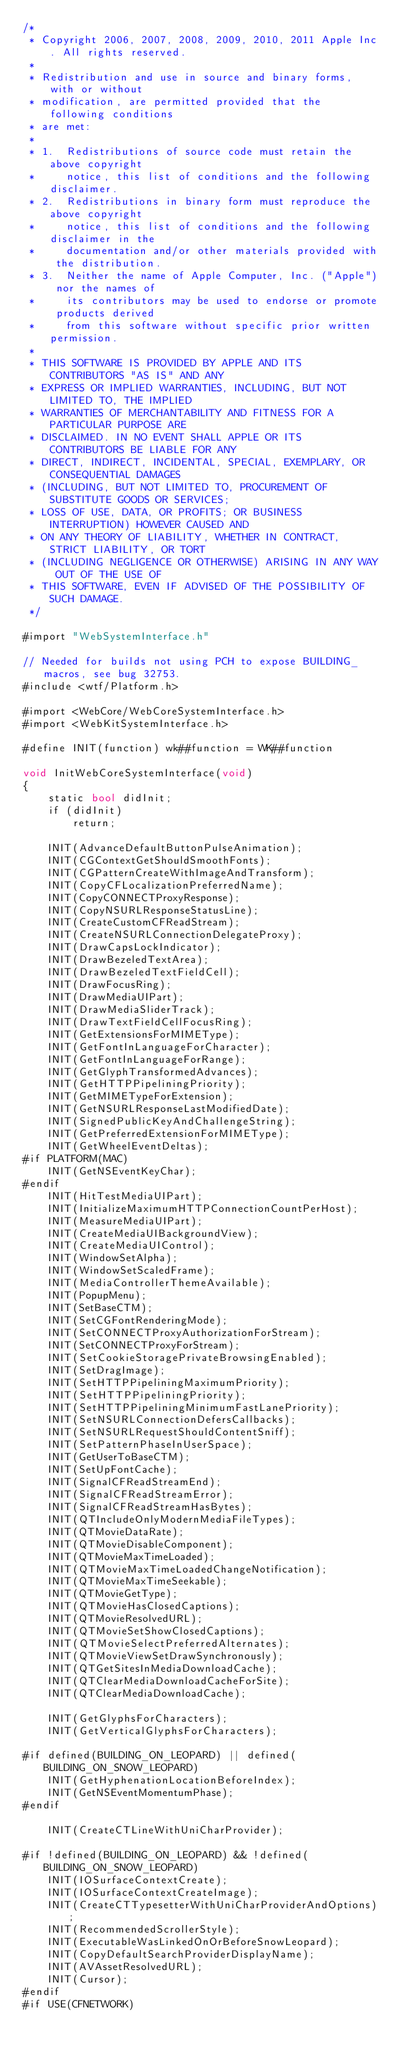<code> <loc_0><loc_0><loc_500><loc_500><_ObjectiveC_>/*
 * Copyright 2006, 2007, 2008, 2009, 2010, 2011 Apple Inc. All rights reserved.
 *
 * Redistribution and use in source and binary forms, with or without
 * modification, are permitted provided that the following conditions
 * are met:
 *
 * 1.  Redistributions of source code must retain the above copyright
 *     notice, this list of conditions and the following disclaimer. 
 * 2.  Redistributions in binary form must reproduce the above copyright
 *     notice, this list of conditions and the following disclaimer in the
 *     documentation and/or other materials provided with the distribution. 
 * 3.  Neither the name of Apple Computer, Inc. ("Apple") nor the names of
 *     its contributors may be used to endorse or promote products derived
 *     from this software without specific prior written permission. 
 *
 * THIS SOFTWARE IS PROVIDED BY APPLE AND ITS CONTRIBUTORS "AS IS" AND ANY
 * EXPRESS OR IMPLIED WARRANTIES, INCLUDING, BUT NOT LIMITED TO, THE IMPLIED
 * WARRANTIES OF MERCHANTABILITY AND FITNESS FOR A PARTICULAR PURPOSE ARE
 * DISCLAIMED. IN NO EVENT SHALL APPLE OR ITS CONTRIBUTORS BE LIABLE FOR ANY
 * DIRECT, INDIRECT, INCIDENTAL, SPECIAL, EXEMPLARY, OR CONSEQUENTIAL DAMAGES
 * (INCLUDING, BUT NOT LIMITED TO, PROCUREMENT OF SUBSTITUTE GOODS OR SERVICES;
 * LOSS OF USE, DATA, OR PROFITS; OR BUSINESS INTERRUPTION) HOWEVER CAUSED AND
 * ON ANY THEORY OF LIABILITY, WHETHER IN CONTRACT, STRICT LIABILITY, OR TORT
 * (INCLUDING NEGLIGENCE OR OTHERWISE) ARISING IN ANY WAY OUT OF THE USE OF
 * THIS SOFTWARE, EVEN IF ADVISED OF THE POSSIBILITY OF SUCH DAMAGE.
 */

#import "WebSystemInterface.h"

// Needed for builds not using PCH to expose BUILDING_ macros, see bug 32753.
#include <wtf/Platform.h>

#import <WebCore/WebCoreSystemInterface.h>
#import <WebKitSystemInterface.h>

#define INIT(function) wk##function = WK##function

void InitWebCoreSystemInterface(void)
{
    static bool didInit;
    if (didInit)
        return;

    INIT(AdvanceDefaultButtonPulseAnimation);
    INIT(CGContextGetShouldSmoothFonts);
    INIT(CGPatternCreateWithImageAndTransform);
    INIT(CopyCFLocalizationPreferredName);
    INIT(CopyCONNECTProxyResponse);
    INIT(CopyNSURLResponseStatusLine);
    INIT(CreateCustomCFReadStream);
    INIT(CreateNSURLConnectionDelegateProxy);
    INIT(DrawCapsLockIndicator);
    INIT(DrawBezeledTextArea);
    INIT(DrawBezeledTextFieldCell);
    INIT(DrawFocusRing);
    INIT(DrawMediaUIPart);
    INIT(DrawMediaSliderTrack);
    INIT(DrawTextFieldCellFocusRing);
    INIT(GetExtensionsForMIMEType);
    INIT(GetFontInLanguageForCharacter);
    INIT(GetFontInLanguageForRange);
    INIT(GetGlyphTransformedAdvances);
    INIT(GetHTTPPipeliningPriority);
    INIT(GetMIMETypeForExtension);
    INIT(GetNSURLResponseLastModifiedDate);
    INIT(SignedPublicKeyAndChallengeString);
    INIT(GetPreferredExtensionForMIMEType);
    INIT(GetWheelEventDeltas);
#if PLATFORM(MAC)
    INIT(GetNSEventKeyChar);
#endif
    INIT(HitTestMediaUIPart);
    INIT(InitializeMaximumHTTPConnectionCountPerHost);
    INIT(MeasureMediaUIPart);
    INIT(CreateMediaUIBackgroundView);
    INIT(CreateMediaUIControl);
    INIT(WindowSetAlpha);
    INIT(WindowSetScaledFrame);
    INIT(MediaControllerThemeAvailable);
    INIT(PopupMenu);
    INIT(SetBaseCTM);
    INIT(SetCGFontRenderingMode);
    INIT(SetCONNECTProxyAuthorizationForStream);
    INIT(SetCONNECTProxyForStream);
    INIT(SetCookieStoragePrivateBrowsingEnabled);
    INIT(SetDragImage);
    INIT(SetHTTPPipeliningMaximumPriority);
    INIT(SetHTTPPipeliningPriority);
    INIT(SetHTTPPipeliningMinimumFastLanePriority);
    INIT(SetNSURLConnectionDefersCallbacks);
    INIT(SetNSURLRequestShouldContentSniff);
    INIT(SetPatternPhaseInUserSpace);
    INIT(GetUserToBaseCTM);
    INIT(SetUpFontCache);
    INIT(SignalCFReadStreamEnd);
    INIT(SignalCFReadStreamError);
    INIT(SignalCFReadStreamHasBytes);
    INIT(QTIncludeOnlyModernMediaFileTypes);
    INIT(QTMovieDataRate);
    INIT(QTMovieDisableComponent);
    INIT(QTMovieMaxTimeLoaded);
    INIT(QTMovieMaxTimeLoadedChangeNotification);
    INIT(QTMovieMaxTimeSeekable);
    INIT(QTMovieGetType);
    INIT(QTMovieHasClosedCaptions);
    INIT(QTMovieResolvedURL);
    INIT(QTMovieSetShowClosedCaptions);
    INIT(QTMovieSelectPreferredAlternates);
    INIT(QTMovieViewSetDrawSynchronously);
    INIT(QTGetSitesInMediaDownloadCache);
    INIT(QTClearMediaDownloadCacheForSite);
    INIT(QTClearMediaDownloadCache);

    INIT(GetGlyphsForCharacters);
    INIT(GetVerticalGlyphsForCharacters);

#if defined(BUILDING_ON_LEOPARD) || defined(BUILDING_ON_SNOW_LEOPARD)
    INIT(GetHyphenationLocationBeforeIndex);
    INIT(GetNSEventMomentumPhase);
#endif

    INIT(CreateCTLineWithUniCharProvider);

#if !defined(BUILDING_ON_LEOPARD) && !defined(BUILDING_ON_SNOW_LEOPARD)
    INIT(IOSurfaceContextCreate);
    INIT(IOSurfaceContextCreateImage);
    INIT(CreateCTTypesetterWithUniCharProviderAndOptions);
    INIT(RecommendedScrollerStyle);
    INIT(ExecutableWasLinkedOnOrBeforeSnowLeopard);
    INIT(CopyDefaultSearchProviderDisplayName);
    INIT(AVAssetResolvedURL);
    INIT(Cursor);
#endif
#if USE(CFNETWORK)</code> 